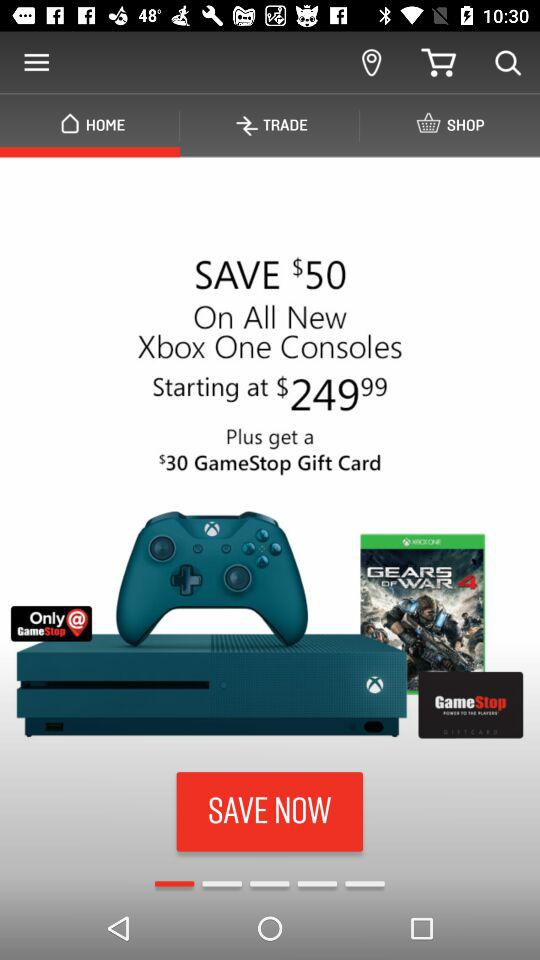How many items are in "SHOP"?
When the provided information is insufficient, respond with <no answer>. <no answer> 